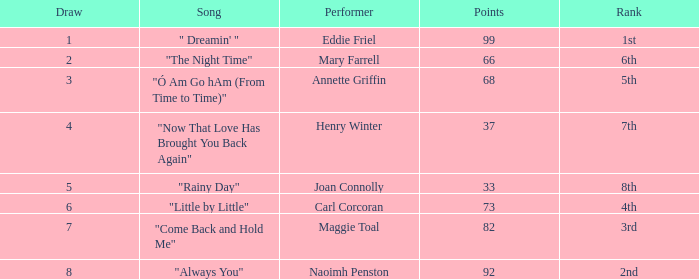I'm looking to parse the entire table for insights. Could you assist me with that? {'header': ['Draw', 'Song', 'Performer', 'Points', 'Rank'], 'rows': [['1', '" Dreamin\' "', 'Eddie Friel', '99', '1st'], ['2', '"The Night Time"', 'Mary Farrell', '66', '6th'], ['3', '"Ó Am Go hAm (From Time to Time)"', 'Annette Griffin', '68', '5th'], ['4', '"Now That Love Has Brought You Back Again"', 'Henry Winter', '37', '7th'], ['5', '"Rainy Day"', 'Joan Connolly', '33', '8th'], ['6', '"Little by Little"', 'Carl Corcoran', '73', '4th'], ['7', '"Come Back and Hold Me"', 'Maggie Toal', '82', '3rd'], ['8', '"Always You"', 'Naoimh Penston', '92', '2nd']]} What are the least points when the standing is 1st? 99.0. 